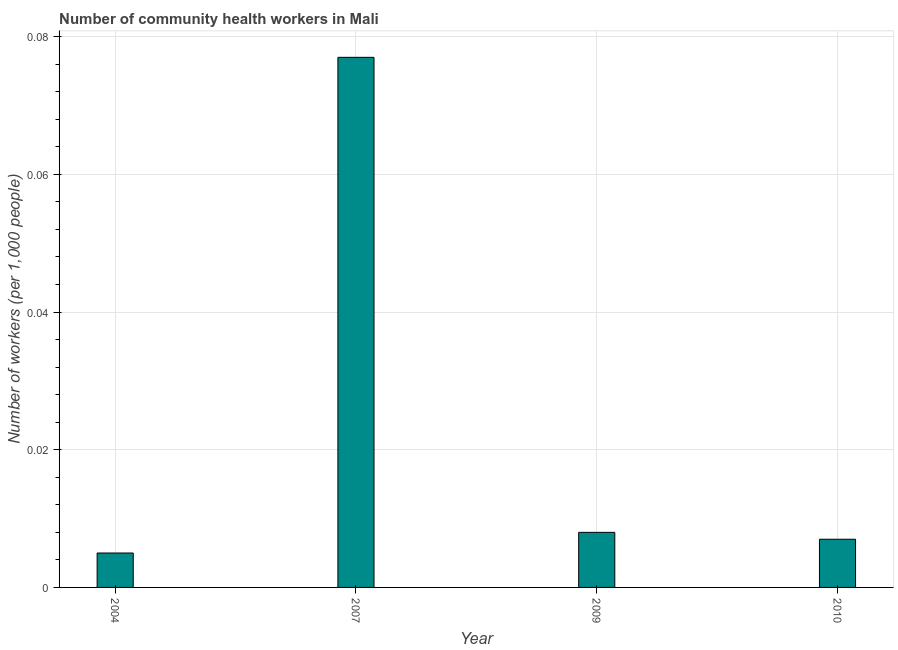What is the title of the graph?
Make the answer very short. Number of community health workers in Mali. What is the label or title of the X-axis?
Offer a terse response. Year. What is the label or title of the Y-axis?
Provide a succinct answer. Number of workers (per 1,0 people). What is the number of community health workers in 2010?
Provide a short and direct response. 0.01. Across all years, what is the maximum number of community health workers?
Provide a short and direct response. 0.08. Across all years, what is the minimum number of community health workers?
Your answer should be compact. 0.01. What is the sum of the number of community health workers?
Give a very brief answer. 0.1. What is the difference between the number of community health workers in 2007 and 2010?
Provide a short and direct response. 0.07. What is the average number of community health workers per year?
Your answer should be very brief. 0.02. What is the median number of community health workers?
Offer a very short reply. 0.01. In how many years, is the number of community health workers greater than 0.04 ?
Your answer should be compact. 1. Do a majority of the years between 2009 and 2010 (inclusive) have number of community health workers greater than 0.04 ?
Offer a terse response. No. What is the ratio of the number of community health workers in 2007 to that in 2009?
Provide a short and direct response. 9.62. What is the difference between the highest and the second highest number of community health workers?
Provide a succinct answer. 0.07. What is the difference between the highest and the lowest number of community health workers?
Keep it short and to the point. 0.07. In how many years, is the number of community health workers greater than the average number of community health workers taken over all years?
Provide a short and direct response. 1. Are all the bars in the graph horizontal?
Make the answer very short. No. How many years are there in the graph?
Provide a short and direct response. 4. Are the values on the major ticks of Y-axis written in scientific E-notation?
Provide a succinct answer. No. What is the Number of workers (per 1,000 people) of 2004?
Provide a short and direct response. 0.01. What is the Number of workers (per 1,000 people) in 2007?
Provide a succinct answer. 0.08. What is the Number of workers (per 1,000 people) in 2009?
Your response must be concise. 0.01. What is the Number of workers (per 1,000 people) of 2010?
Provide a succinct answer. 0.01. What is the difference between the Number of workers (per 1,000 people) in 2004 and 2007?
Provide a succinct answer. -0.07. What is the difference between the Number of workers (per 1,000 people) in 2004 and 2009?
Offer a very short reply. -0. What is the difference between the Number of workers (per 1,000 people) in 2004 and 2010?
Your response must be concise. -0. What is the difference between the Number of workers (per 1,000 people) in 2007 and 2009?
Offer a very short reply. 0.07. What is the difference between the Number of workers (per 1,000 people) in 2007 and 2010?
Give a very brief answer. 0.07. What is the difference between the Number of workers (per 1,000 people) in 2009 and 2010?
Your answer should be compact. 0. What is the ratio of the Number of workers (per 1,000 people) in 2004 to that in 2007?
Give a very brief answer. 0.07. What is the ratio of the Number of workers (per 1,000 people) in 2004 to that in 2009?
Offer a terse response. 0.62. What is the ratio of the Number of workers (per 1,000 people) in 2004 to that in 2010?
Give a very brief answer. 0.71. What is the ratio of the Number of workers (per 1,000 people) in 2007 to that in 2009?
Your response must be concise. 9.62. What is the ratio of the Number of workers (per 1,000 people) in 2007 to that in 2010?
Provide a succinct answer. 11. What is the ratio of the Number of workers (per 1,000 people) in 2009 to that in 2010?
Offer a very short reply. 1.14. 